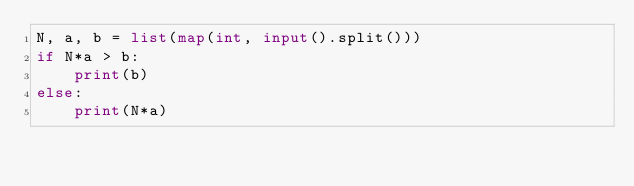Convert code to text. <code><loc_0><loc_0><loc_500><loc_500><_Python_>N, a, b = list(map(int, input().split()))
if N*a > b:
    print(b)
else:
    print(N*a)</code> 